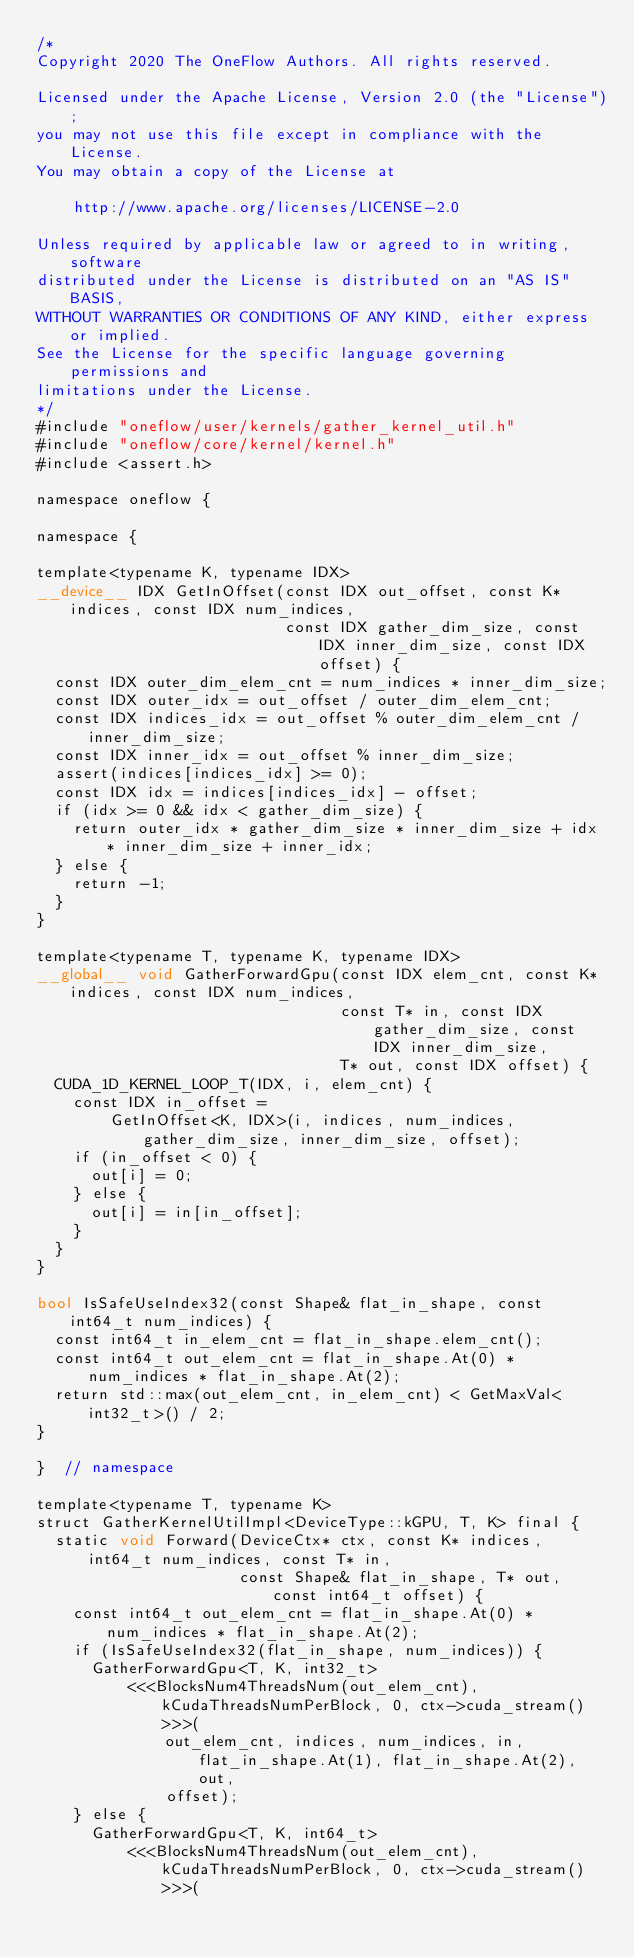Convert code to text. <code><loc_0><loc_0><loc_500><loc_500><_Cuda_>/*
Copyright 2020 The OneFlow Authors. All rights reserved.

Licensed under the Apache License, Version 2.0 (the "License");
you may not use this file except in compliance with the License.
You may obtain a copy of the License at

    http://www.apache.org/licenses/LICENSE-2.0

Unless required by applicable law or agreed to in writing, software
distributed under the License is distributed on an "AS IS" BASIS,
WITHOUT WARRANTIES OR CONDITIONS OF ANY KIND, either express or implied.
See the License for the specific language governing permissions and
limitations under the License.
*/
#include "oneflow/user/kernels/gather_kernel_util.h"
#include "oneflow/core/kernel/kernel.h"
#include <assert.h>

namespace oneflow {

namespace {

template<typename K, typename IDX>
__device__ IDX GetInOffset(const IDX out_offset, const K* indices, const IDX num_indices,
                           const IDX gather_dim_size, const IDX inner_dim_size, const IDX offset) {
  const IDX outer_dim_elem_cnt = num_indices * inner_dim_size;
  const IDX outer_idx = out_offset / outer_dim_elem_cnt;
  const IDX indices_idx = out_offset % outer_dim_elem_cnt / inner_dim_size;
  const IDX inner_idx = out_offset % inner_dim_size;
  assert(indices[indices_idx] >= 0);
  const IDX idx = indices[indices_idx] - offset;
  if (idx >= 0 && idx < gather_dim_size) {
    return outer_idx * gather_dim_size * inner_dim_size + idx * inner_dim_size + inner_idx;
  } else {
    return -1;
  }
}

template<typename T, typename K, typename IDX>
__global__ void GatherForwardGpu(const IDX elem_cnt, const K* indices, const IDX num_indices,
                                 const T* in, const IDX gather_dim_size, const IDX inner_dim_size,
                                 T* out, const IDX offset) {
  CUDA_1D_KERNEL_LOOP_T(IDX, i, elem_cnt) {
    const IDX in_offset =
        GetInOffset<K, IDX>(i, indices, num_indices, gather_dim_size, inner_dim_size, offset);
    if (in_offset < 0) {
      out[i] = 0;
    } else {
      out[i] = in[in_offset];
    }
  }
}

bool IsSafeUseIndex32(const Shape& flat_in_shape, const int64_t num_indices) {
  const int64_t in_elem_cnt = flat_in_shape.elem_cnt();
  const int64_t out_elem_cnt = flat_in_shape.At(0) * num_indices * flat_in_shape.At(2);
  return std::max(out_elem_cnt, in_elem_cnt) < GetMaxVal<int32_t>() / 2;
}

}  // namespace

template<typename T, typename K>
struct GatherKernelUtilImpl<DeviceType::kGPU, T, K> final {
  static void Forward(DeviceCtx* ctx, const K* indices, int64_t num_indices, const T* in,
                      const Shape& flat_in_shape, T* out, const int64_t offset) {
    const int64_t out_elem_cnt = flat_in_shape.At(0) * num_indices * flat_in_shape.At(2);
    if (IsSafeUseIndex32(flat_in_shape, num_indices)) {
      GatherForwardGpu<T, K, int32_t>
          <<<BlocksNum4ThreadsNum(out_elem_cnt), kCudaThreadsNumPerBlock, 0, ctx->cuda_stream()>>>(
              out_elem_cnt, indices, num_indices, in, flat_in_shape.At(1), flat_in_shape.At(2), out,
              offset);
    } else {
      GatherForwardGpu<T, K, int64_t>
          <<<BlocksNum4ThreadsNum(out_elem_cnt), kCudaThreadsNumPerBlock, 0, ctx->cuda_stream()>>>(</code> 